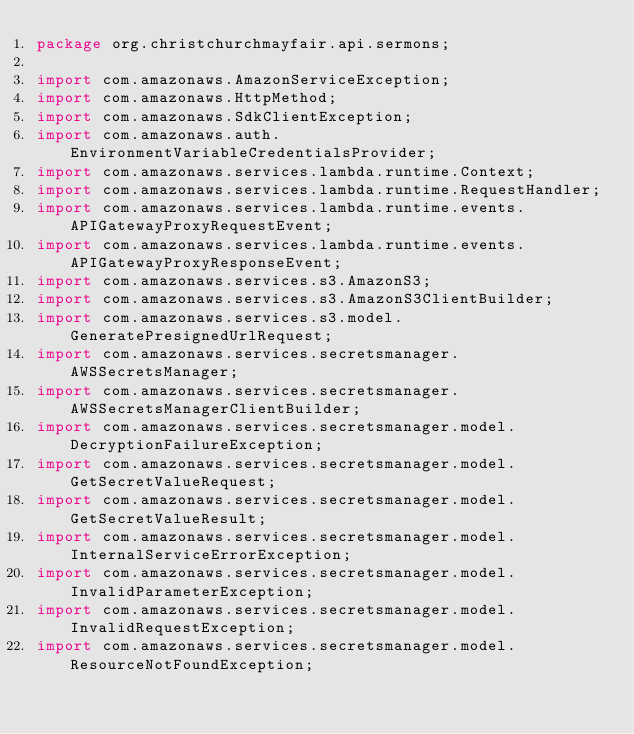<code> <loc_0><loc_0><loc_500><loc_500><_Java_>package org.christchurchmayfair.api.sermons;

import com.amazonaws.AmazonServiceException;
import com.amazonaws.HttpMethod;
import com.amazonaws.SdkClientException;
import com.amazonaws.auth.EnvironmentVariableCredentialsProvider;
import com.amazonaws.services.lambda.runtime.Context;
import com.amazonaws.services.lambda.runtime.RequestHandler;
import com.amazonaws.services.lambda.runtime.events.APIGatewayProxyRequestEvent;
import com.amazonaws.services.lambda.runtime.events.APIGatewayProxyResponseEvent;
import com.amazonaws.services.s3.AmazonS3;
import com.amazonaws.services.s3.AmazonS3ClientBuilder;
import com.amazonaws.services.s3.model.GeneratePresignedUrlRequest;
import com.amazonaws.services.secretsmanager.AWSSecretsManager;
import com.amazonaws.services.secretsmanager.AWSSecretsManagerClientBuilder;
import com.amazonaws.services.secretsmanager.model.DecryptionFailureException;
import com.amazonaws.services.secretsmanager.model.GetSecretValueRequest;
import com.amazonaws.services.secretsmanager.model.GetSecretValueResult;
import com.amazonaws.services.secretsmanager.model.InternalServiceErrorException;
import com.amazonaws.services.secretsmanager.model.InvalidParameterException;
import com.amazonaws.services.secretsmanager.model.InvalidRequestException;
import com.amazonaws.services.secretsmanager.model.ResourceNotFoundException;</code> 